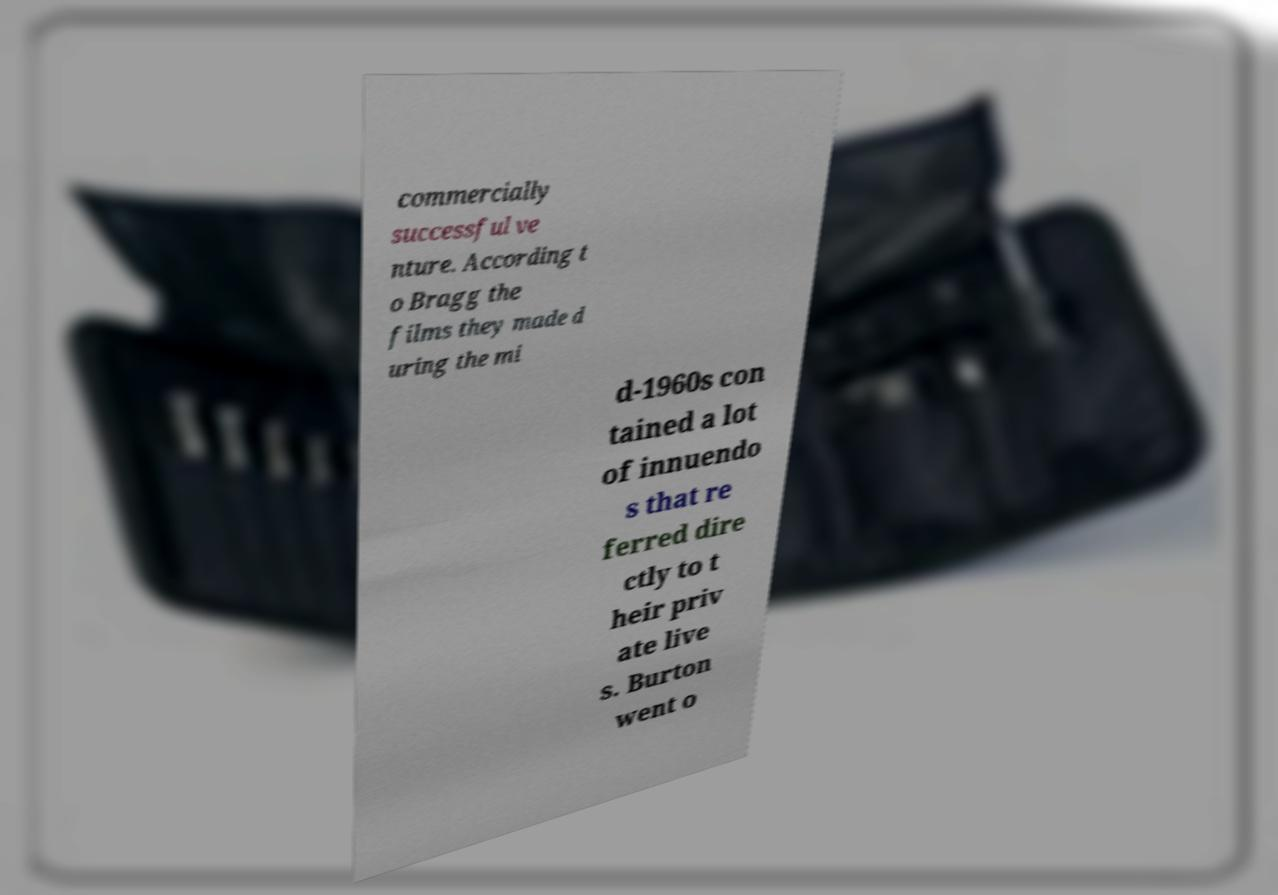Please read and relay the text visible in this image. What does it say? commercially successful ve nture. According t o Bragg the films they made d uring the mi d-1960s con tained a lot of innuendo s that re ferred dire ctly to t heir priv ate live s. Burton went o 